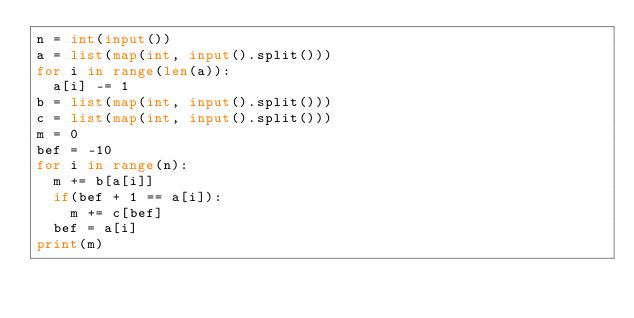<code> <loc_0><loc_0><loc_500><loc_500><_Python_>n = int(input())
a = list(map(int, input().split()))
for i in range(len(a)):
  a[i] -= 1
b = list(map(int, input().split()))
c = list(map(int, input().split()))
m = 0
bef = -10
for i in range(n):
  m += b[a[i]]
  if(bef + 1 == a[i]):
    m += c[bef]
  bef = a[i]
print(m)</code> 